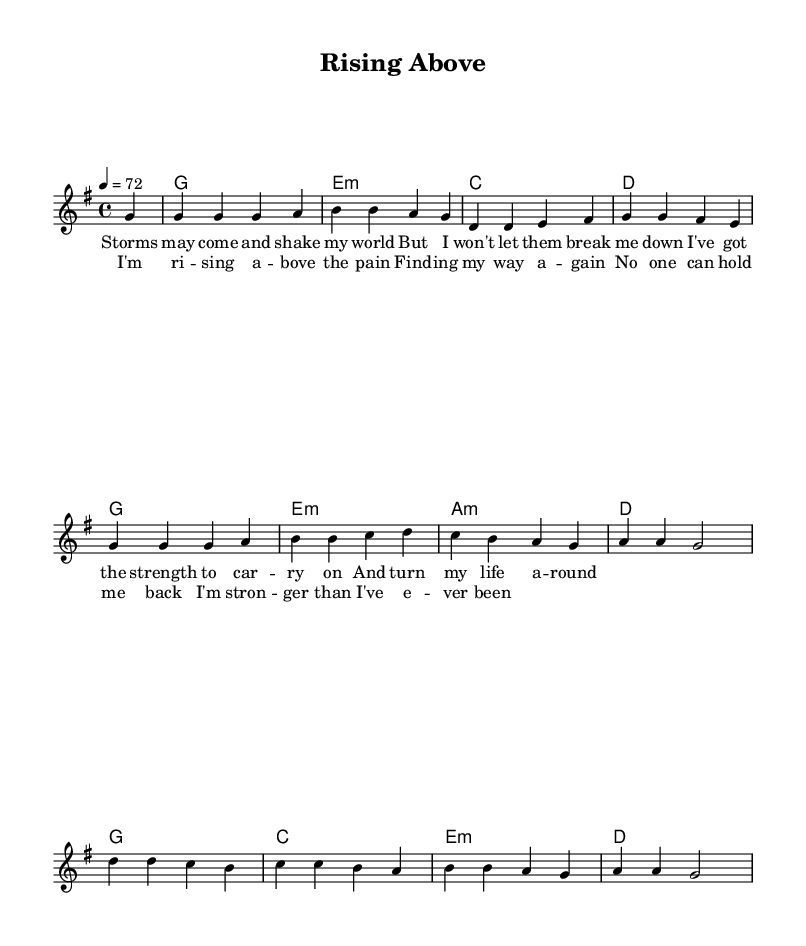What is the key signature of this music? The key signature appears as a single sharp on the staff, indicating that the piece is in G major. G major has one sharp (F#).
Answer: G major What is the time signature of this piece? The time signature is indicated at the beginning of the score as 4/4, which means there are four beats in each measure and the quarter note gets one beat.
Answer: 4/4 What is the tempo marking of the music? The tempo marking shown in the score is "4 = 72," indicating that there are 72 quarter-note beats in a minute.
Answer: 72 How many measures are there in the verse? Counting the measures indicated in the verse section, there are a total of 4 measures that make up the verse part.
Answer: 4 What is the first note of the melody? The melody begins with a G note, as indicated in the first measure, where a G note is played after a four-count pause.
Answer: G What is the function of the E minor chord in the harmonies? The E minor chord serves as the second chord in the progression, providing a minor tonality that contrasts with the tonic G major chord, adding depth to the harmony.
Answer: Second chord What is the lyrical theme of this song? The lyrics focus on self-empowerment and resilience, addressing themes of overcoming challenges and finding strength within oneself.
Answer: Self-empowerment 